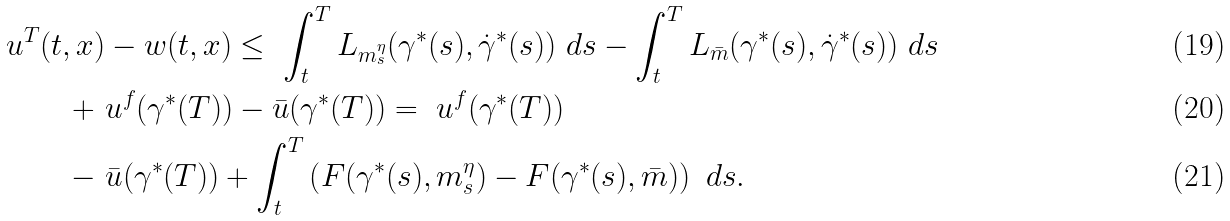Convert formula to latex. <formula><loc_0><loc_0><loc_500><loc_500>u ^ { T } ( t , x ) & - w ( t , x ) \leq \ \int _ { t } ^ { T } { L _ { m ^ { \eta } _ { s } } ( \gamma ^ { * } ( s ) , \dot { \gamma } ^ { * } ( s ) ) \ d s } - \int _ { t } ^ { T } { L _ { \bar { m } } ( \gamma ^ { * } ( s ) , \dot { \gamma } ^ { * } ( s ) ) \ d s } \\ + \ & u ^ { f } ( \gamma ^ { * } ( T ) ) - \bar { u } ( \gamma ^ { * } ( T ) ) = \ u ^ { f } ( \gamma ^ { * } ( T ) ) \\ - \ & \bar { u } ( \gamma ^ { * } ( T ) ) + \int _ { t } ^ { T } { \left ( F ( \gamma ^ { * } ( s ) , m ^ { \eta } _ { s } ) - F ( \gamma ^ { * } ( s ) , \bar { m } ) \right ) \ d s } .</formula> 